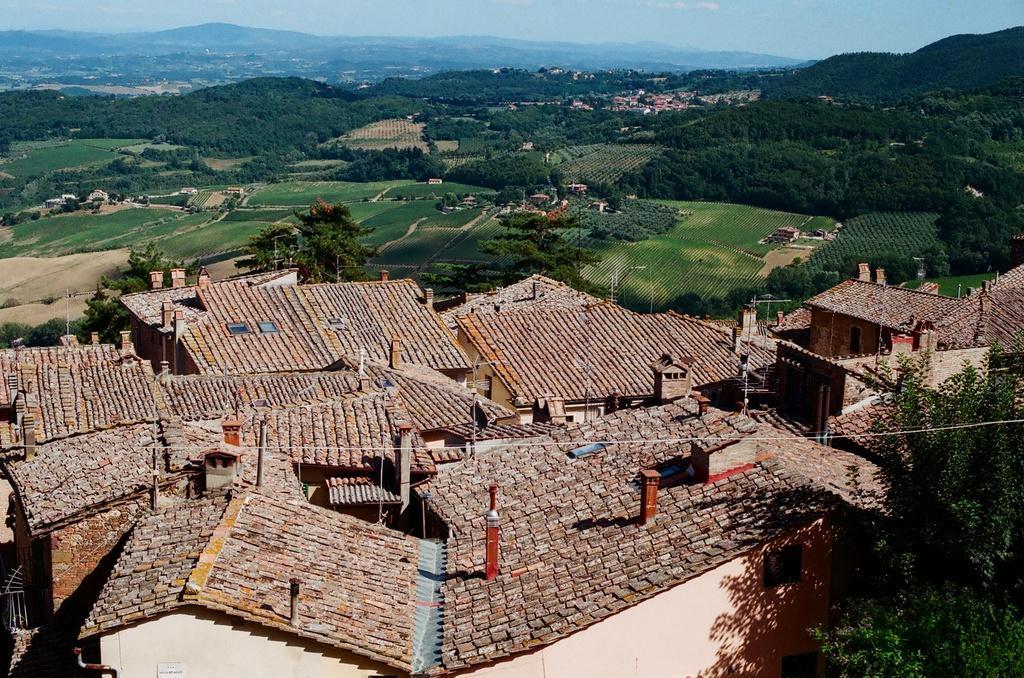How would you summarize this image in a sentence or two? In this image in the foreground there are buildings. In the right there is a tree. In the background there are trees, buildings, hills and sky. 